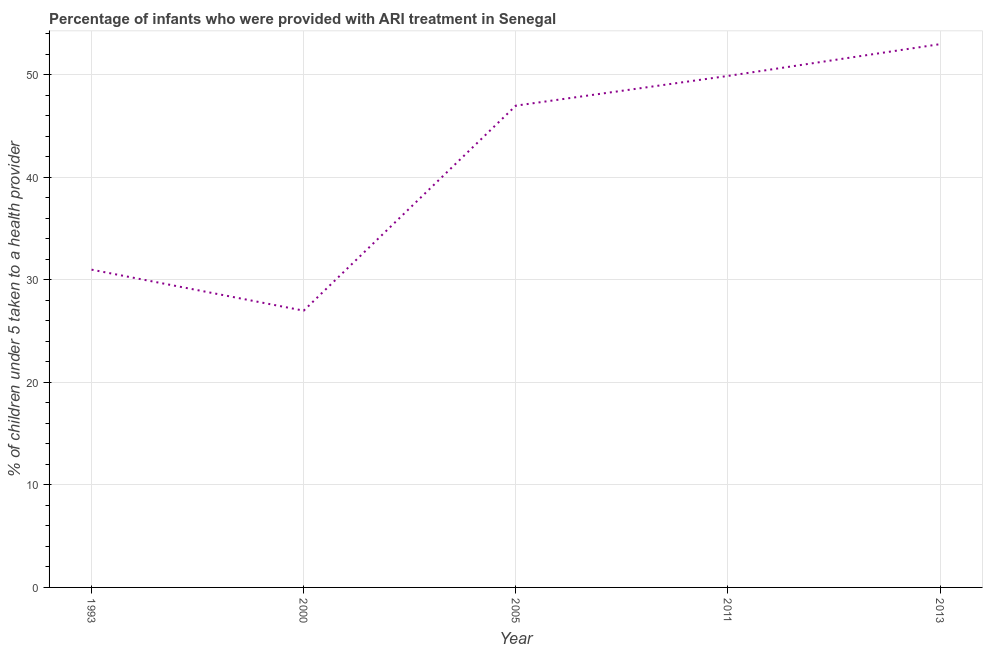What is the percentage of children who were provided with ari treatment in 2011?
Keep it short and to the point. 49.9. Across all years, what is the minimum percentage of children who were provided with ari treatment?
Offer a terse response. 27. In which year was the percentage of children who were provided with ari treatment maximum?
Make the answer very short. 2013. What is the sum of the percentage of children who were provided with ari treatment?
Offer a terse response. 207.9. What is the average percentage of children who were provided with ari treatment per year?
Offer a terse response. 41.58. In how many years, is the percentage of children who were provided with ari treatment greater than 46 %?
Ensure brevity in your answer.  3. Do a majority of the years between 2000 and 2005 (inclusive) have percentage of children who were provided with ari treatment greater than 14 %?
Make the answer very short. Yes. What is the ratio of the percentage of children who were provided with ari treatment in 1993 to that in 2013?
Provide a short and direct response. 0.58. What is the difference between the highest and the second highest percentage of children who were provided with ari treatment?
Your answer should be very brief. 3.1. Is the sum of the percentage of children who were provided with ari treatment in 2000 and 2011 greater than the maximum percentage of children who were provided with ari treatment across all years?
Offer a terse response. Yes. What is the difference between the highest and the lowest percentage of children who were provided with ari treatment?
Make the answer very short. 26. In how many years, is the percentage of children who were provided with ari treatment greater than the average percentage of children who were provided with ari treatment taken over all years?
Make the answer very short. 3. How many lines are there?
Your answer should be compact. 1. What is the title of the graph?
Provide a succinct answer. Percentage of infants who were provided with ARI treatment in Senegal. What is the label or title of the X-axis?
Provide a short and direct response. Year. What is the label or title of the Y-axis?
Offer a very short reply. % of children under 5 taken to a health provider. What is the % of children under 5 taken to a health provider in 2005?
Make the answer very short. 47. What is the % of children under 5 taken to a health provider in 2011?
Provide a succinct answer. 49.9. What is the % of children under 5 taken to a health provider of 2013?
Keep it short and to the point. 53. What is the difference between the % of children under 5 taken to a health provider in 1993 and 2000?
Offer a very short reply. 4. What is the difference between the % of children under 5 taken to a health provider in 1993 and 2011?
Keep it short and to the point. -18.9. What is the difference between the % of children under 5 taken to a health provider in 2000 and 2011?
Your answer should be compact. -22.9. What is the difference between the % of children under 5 taken to a health provider in 2005 and 2011?
Your response must be concise. -2.9. What is the difference between the % of children under 5 taken to a health provider in 2005 and 2013?
Provide a short and direct response. -6. What is the difference between the % of children under 5 taken to a health provider in 2011 and 2013?
Give a very brief answer. -3.1. What is the ratio of the % of children under 5 taken to a health provider in 1993 to that in 2000?
Make the answer very short. 1.15. What is the ratio of the % of children under 5 taken to a health provider in 1993 to that in 2005?
Your response must be concise. 0.66. What is the ratio of the % of children under 5 taken to a health provider in 1993 to that in 2011?
Offer a very short reply. 0.62. What is the ratio of the % of children under 5 taken to a health provider in 1993 to that in 2013?
Your answer should be very brief. 0.58. What is the ratio of the % of children under 5 taken to a health provider in 2000 to that in 2005?
Your answer should be very brief. 0.57. What is the ratio of the % of children under 5 taken to a health provider in 2000 to that in 2011?
Give a very brief answer. 0.54. What is the ratio of the % of children under 5 taken to a health provider in 2000 to that in 2013?
Your answer should be very brief. 0.51. What is the ratio of the % of children under 5 taken to a health provider in 2005 to that in 2011?
Your answer should be very brief. 0.94. What is the ratio of the % of children under 5 taken to a health provider in 2005 to that in 2013?
Keep it short and to the point. 0.89. What is the ratio of the % of children under 5 taken to a health provider in 2011 to that in 2013?
Give a very brief answer. 0.94. 